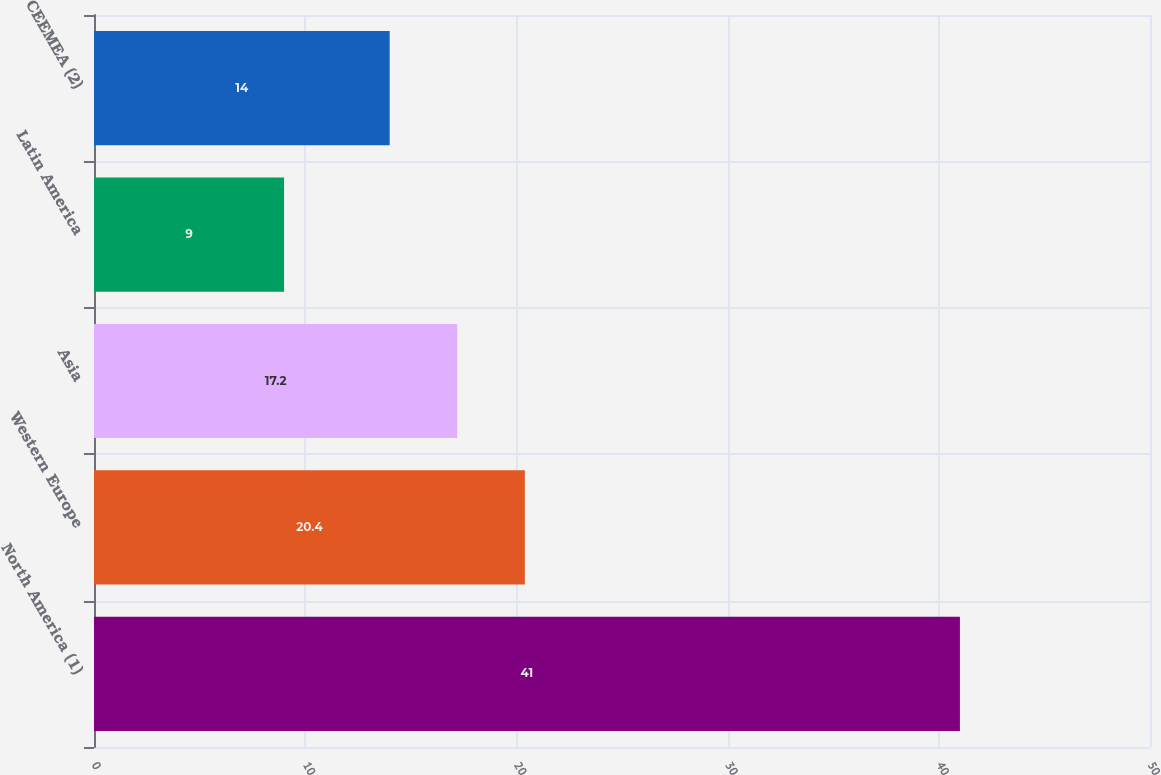Convert chart. <chart><loc_0><loc_0><loc_500><loc_500><bar_chart><fcel>North America (1)<fcel>Western Europe<fcel>Asia<fcel>Latin America<fcel>CEEMEA (2)<nl><fcel>41<fcel>20.4<fcel>17.2<fcel>9<fcel>14<nl></chart> 